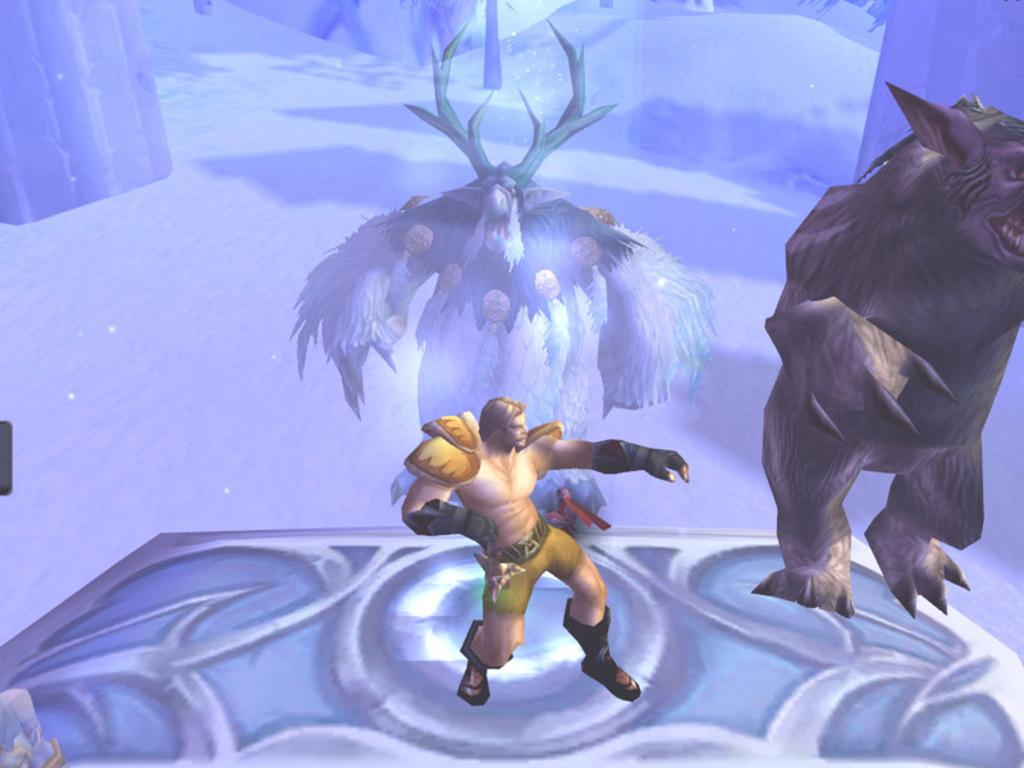What type of animal is present in the image? There is an animal in the image. Who else is present in the image besides the animal? There is a man standing in the image. Where is the man standing? The man is standing on the floor. What can be seen in the background of the image? There is an animal in the background of the image, and the ground is covered with snow. What type of camp can be seen in the image? There is no camp present in the image. What side of the animal is visible in the image? The facts provided do not specify which side of the animal is visible in the image. 